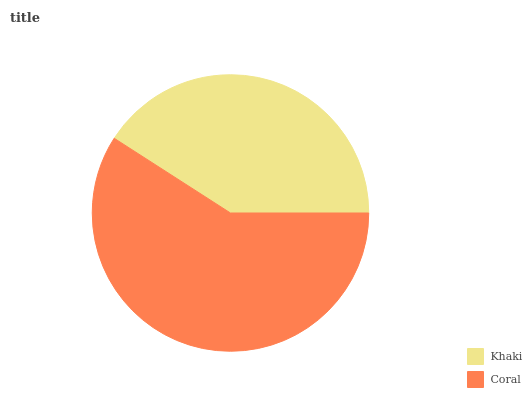Is Khaki the minimum?
Answer yes or no. Yes. Is Coral the maximum?
Answer yes or no. Yes. Is Coral the minimum?
Answer yes or no. No. Is Coral greater than Khaki?
Answer yes or no. Yes. Is Khaki less than Coral?
Answer yes or no. Yes. Is Khaki greater than Coral?
Answer yes or no. No. Is Coral less than Khaki?
Answer yes or no. No. Is Coral the high median?
Answer yes or no. Yes. Is Khaki the low median?
Answer yes or no. Yes. Is Khaki the high median?
Answer yes or no. No. Is Coral the low median?
Answer yes or no. No. 